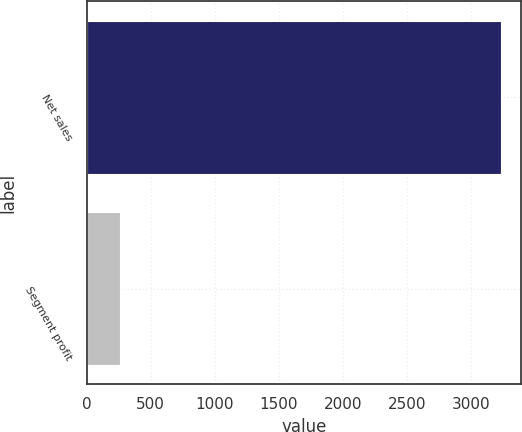Convert chart to OTSL. <chart><loc_0><loc_0><loc_500><loc_500><bar_chart><fcel>Net sales<fcel>Segment profit<nl><fcel>3234<fcel>257<nl></chart> 